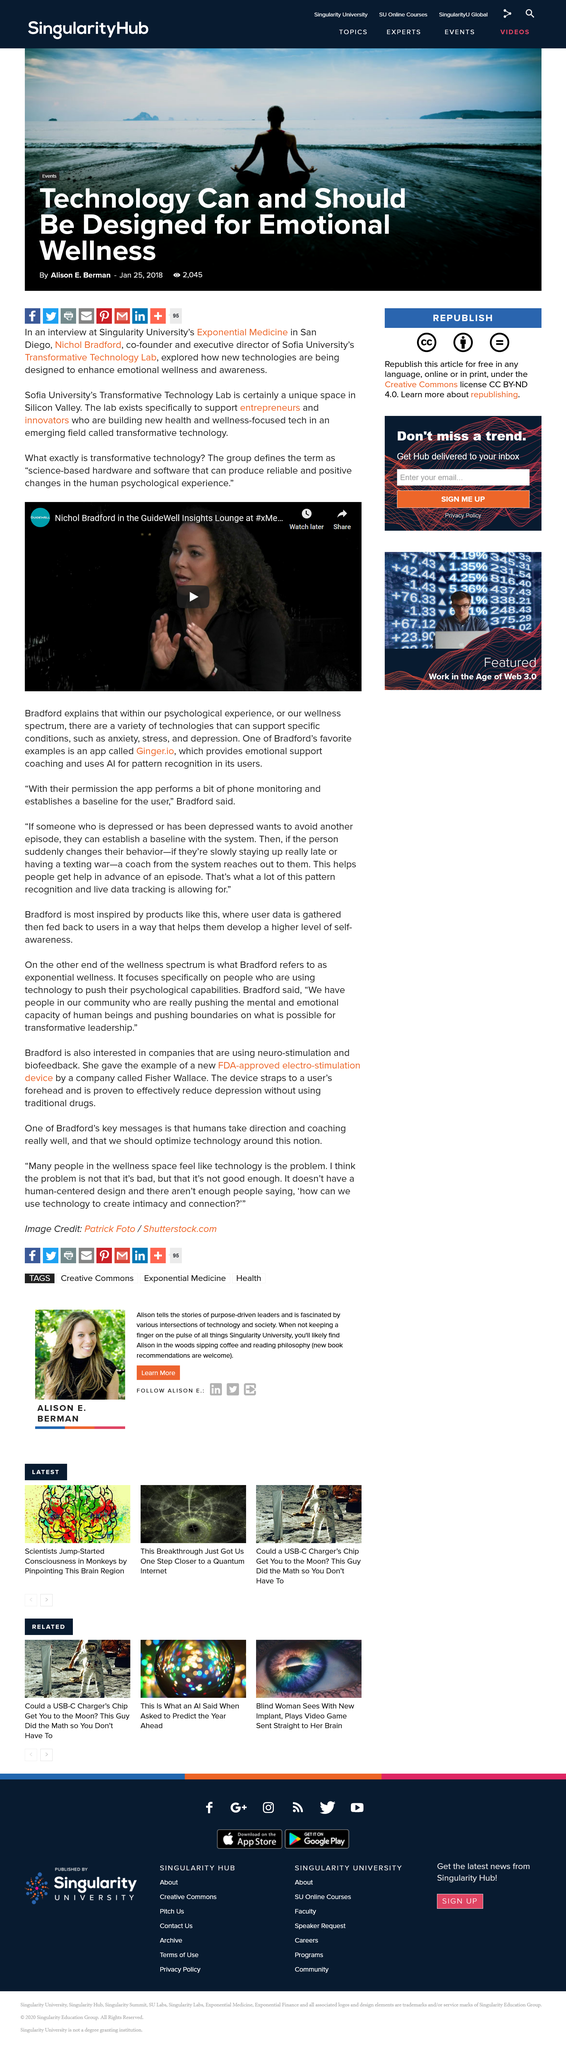Outline some significant characteristics in this image. Ginger.io is an app that provides emotional support coaching and is known for its ability to offer support and guidance to individuals seeking to improve their emotional well-being. Transformative technology is a science-based hardware and software that produces reliable and positive changes in the human psychological experience, as defined. It is true that Nichol Bradford discusses our psychological experience in the video. 